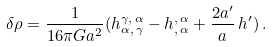Convert formula to latex. <formula><loc_0><loc_0><loc_500><loc_500>\delta \rho = \frac { 1 } { 1 6 \pi G a ^ { 2 } } ( h ^ { \gamma , \, \alpha } _ { \alpha , \, \gamma } - h ^ { , \, \alpha } _ { , \, \alpha } + \frac { 2 a ^ { \prime } } { a } \, h ^ { \prime } ) \, .</formula> 